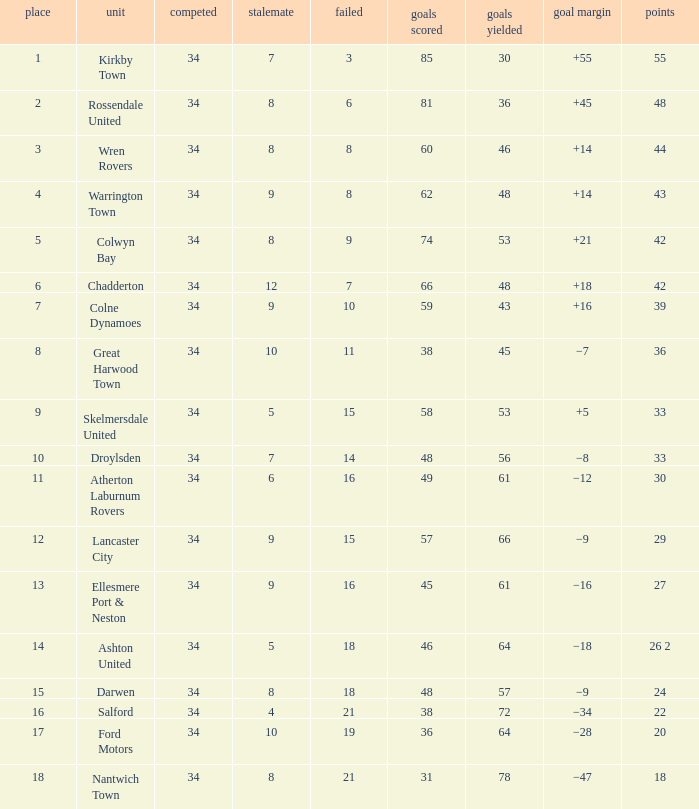What is the smallest number of goals against when there are 1 of 18 points, and more than 8 are drawn? None. 